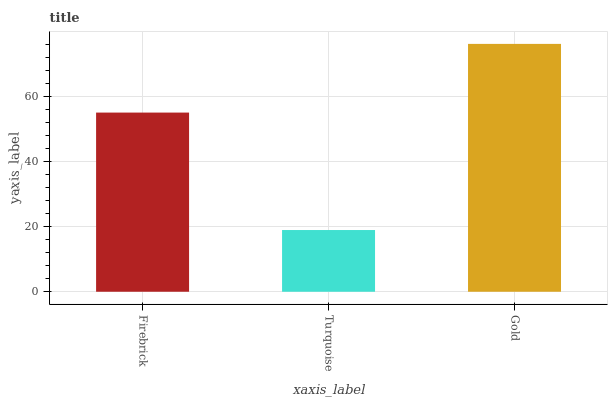Is Gold the minimum?
Answer yes or no. No. Is Turquoise the maximum?
Answer yes or no. No. Is Gold greater than Turquoise?
Answer yes or no. Yes. Is Turquoise less than Gold?
Answer yes or no. Yes. Is Turquoise greater than Gold?
Answer yes or no. No. Is Gold less than Turquoise?
Answer yes or no. No. Is Firebrick the high median?
Answer yes or no. Yes. Is Firebrick the low median?
Answer yes or no. Yes. Is Turquoise the high median?
Answer yes or no. No. Is Gold the low median?
Answer yes or no. No. 